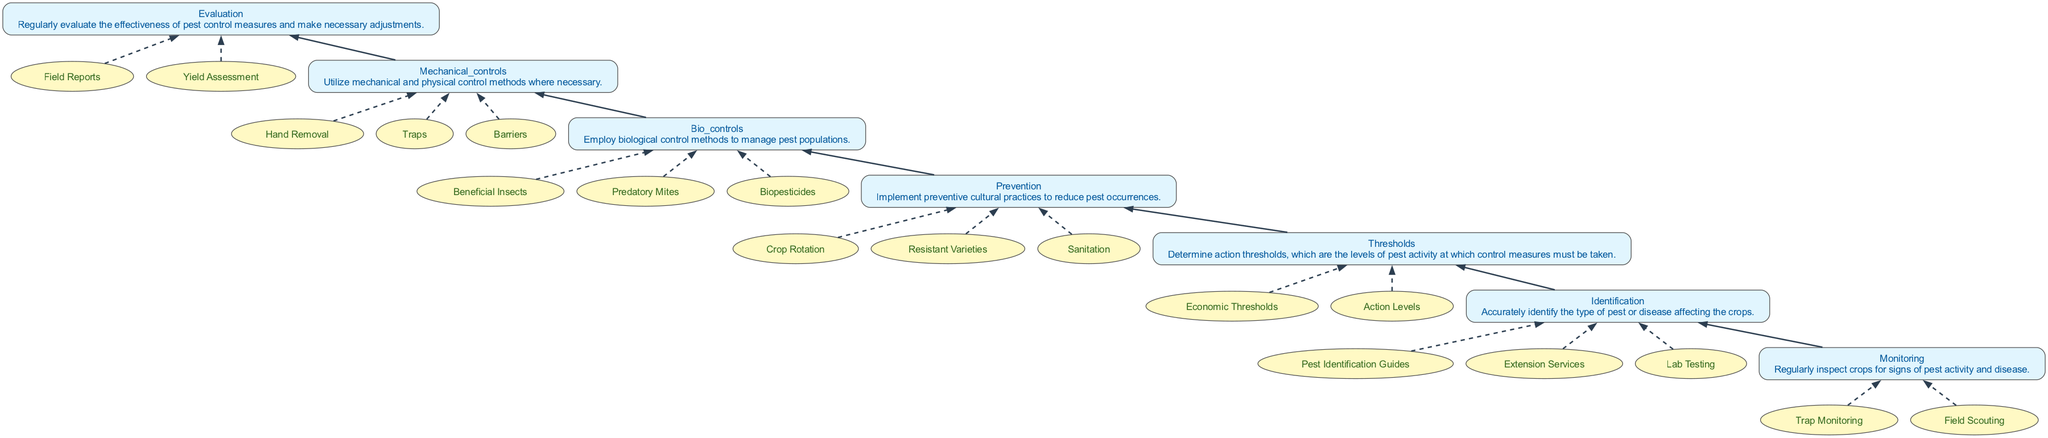What is the first step in the Integrated Pest Management process? The diagram flows from the bottom to the top, and the first step at the bottom is "Monitoring".
Answer: Monitoring How many levels are there in the Integrated Pest Management process? By counting the levels in the diagram, we see there are 7 levels total: Monitoring, Identification, Thresholds, Prevention, Bio Controls, Mechanical Controls, and Evaluation.
Answer: 7 Which level comes after "Thresholds"? In the sequence presented in the diagram, "Prevention" is the level that comes after "Thresholds".
Answer: Prevention What types of entities are associated with "Bio Controls"? The real-world entities linked to "Bio Controls" in the diagram include "Beneficial Insects," "Predatory Mites," and "Biopesticides".
Answer: Beneficial Insects, Predatory Mites, Biopesticides What is the purpose of the "Evaluation" level? The description associated with the "Evaluation" level indicates that its purpose is to regularly assess the effectiveness of pest control measures and make necessary adjustments.
Answer: Assess effectiveness How does "Prevention" relate to "Identification"? In the flow chart, "Prevention" follows "Thresholds" which means that after identifying the pests, preventive measures are implemented to avoid future infestations.
Answer: Prevention follows Identification What type of controls are suggested in the "Mechanical Controls" level? The diagram indicates that "Mechanical Controls" may include methods such as "Hand Removal," "Traps," and "Barriers" to manage pest populations.
Answer: Hand Removal, Traps, Barriers What do "Economic Thresholds" relate to in this process? "Economic Thresholds" are part of the "Thresholds" level, which determines the pest activity levels that necessitate control measures.
Answer: Pest activity levels At which point do you employ biological controls? Biological controls are employed at the "Bio Controls" level, which follows the "Prevention" level in the diagram.
Answer: Bio Controls level 